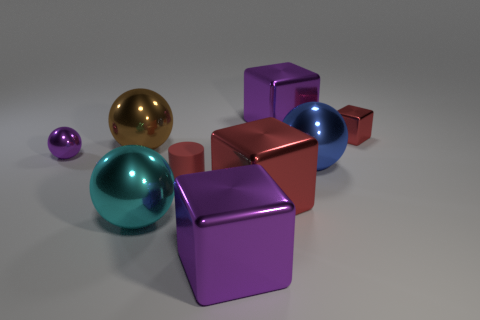Subtract 1 cubes. How many cubes are left? 3 Add 1 cyan spheres. How many objects exist? 10 Subtract all cylinders. How many objects are left? 8 Add 7 large red matte cylinders. How many large red matte cylinders exist? 7 Subtract 0 gray balls. How many objects are left? 9 Subtract all tiny gray metallic things. Subtract all purple shiny blocks. How many objects are left? 7 Add 4 cyan spheres. How many cyan spheres are left? 5 